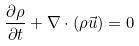<formula> <loc_0><loc_0><loc_500><loc_500>\frac { \partial \rho } { \partial t } + \nabla \cdot ( \rho \vec { u } ) = 0</formula> 